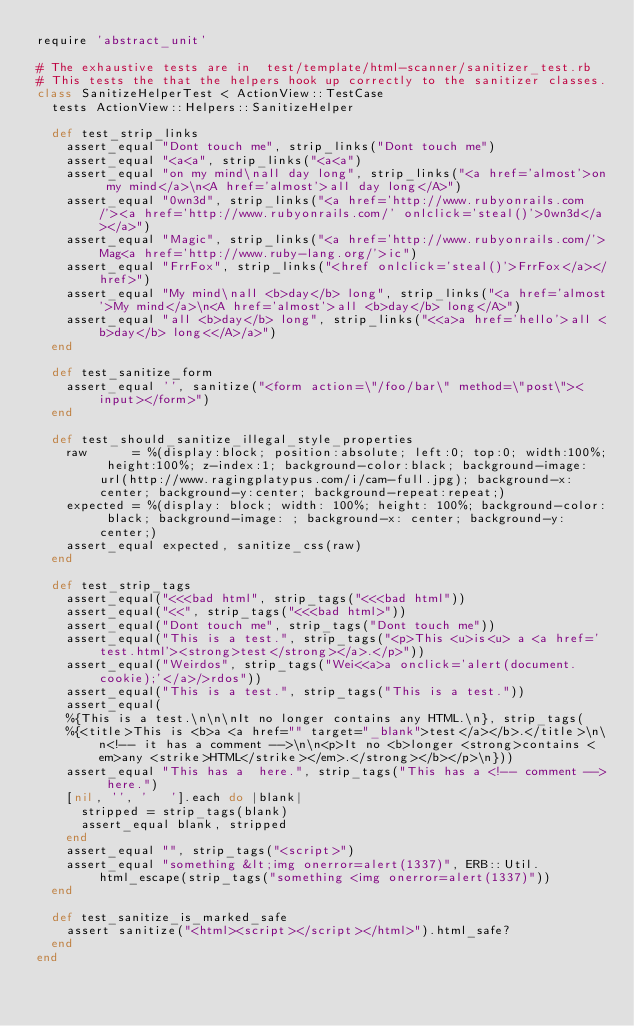<code> <loc_0><loc_0><loc_500><loc_500><_Ruby_>require 'abstract_unit'

# The exhaustive tests are in  test/template/html-scanner/sanitizer_test.rb
# This tests the that the helpers hook up correctly to the sanitizer classes.
class SanitizeHelperTest < ActionView::TestCase
  tests ActionView::Helpers::SanitizeHelper

  def test_strip_links
    assert_equal "Dont touch me", strip_links("Dont touch me")
    assert_equal "<a<a", strip_links("<a<a")
    assert_equal "on my mind\nall day long", strip_links("<a href='almost'>on my mind</a>\n<A href='almost'>all day long</A>")
    assert_equal "0wn3d", strip_links("<a href='http://www.rubyonrails.com/'><a href='http://www.rubyonrails.com/' onlclick='steal()'>0wn3d</a></a>")
    assert_equal "Magic", strip_links("<a href='http://www.rubyonrails.com/'>Mag<a href='http://www.ruby-lang.org/'>ic")
    assert_equal "FrrFox", strip_links("<href onlclick='steal()'>FrrFox</a></href>")
    assert_equal "My mind\nall <b>day</b> long", strip_links("<a href='almost'>My mind</a>\n<A href='almost'>all <b>day</b> long</A>")
    assert_equal "all <b>day</b> long", strip_links("<<a>a href='hello'>all <b>day</b> long<</A>/a>")
  end

  def test_sanitize_form
    assert_equal '', sanitize("<form action=\"/foo/bar\" method=\"post\"><input></form>")
  end

  def test_should_sanitize_illegal_style_properties
    raw      = %(display:block; position:absolute; left:0; top:0; width:100%; height:100%; z-index:1; background-color:black; background-image:url(http://www.ragingplatypus.com/i/cam-full.jpg); background-x:center; background-y:center; background-repeat:repeat;)
    expected = %(display: block; width: 100%; height: 100%; background-color: black; background-image: ; background-x: center; background-y: center;)
    assert_equal expected, sanitize_css(raw)
  end

  def test_strip_tags
    assert_equal("<<<bad html", strip_tags("<<<bad html"))
    assert_equal("<<", strip_tags("<<<bad html>"))
    assert_equal("Dont touch me", strip_tags("Dont touch me"))
    assert_equal("This is a test.", strip_tags("<p>This <u>is<u> a <a href='test.html'><strong>test</strong></a>.</p>"))
    assert_equal("Weirdos", strip_tags("Wei<<a>a onclick='alert(document.cookie);'</a>/>rdos"))
    assert_equal("This is a test.", strip_tags("This is a test."))
    assert_equal(
    %{This is a test.\n\n\nIt no longer contains any HTML.\n}, strip_tags(
    %{<title>This is <b>a <a href="" target="_blank">test</a></b>.</title>\n\n<!-- it has a comment -->\n\n<p>It no <b>longer <strong>contains <em>any <strike>HTML</strike></em>.</strong></b></p>\n}))
    assert_equal "This has a  here.", strip_tags("This has a <!-- comment --> here.")
    [nil, '', '   '].each do |blank|
      stripped = strip_tags(blank)
      assert_equal blank, stripped
    end
    assert_equal "", strip_tags("<script>")
    assert_equal "something &lt;img onerror=alert(1337)", ERB::Util.html_escape(strip_tags("something <img onerror=alert(1337)"))
  end

  def test_sanitize_is_marked_safe
    assert sanitize("<html><script></script></html>").html_safe?
  end
end
</code> 